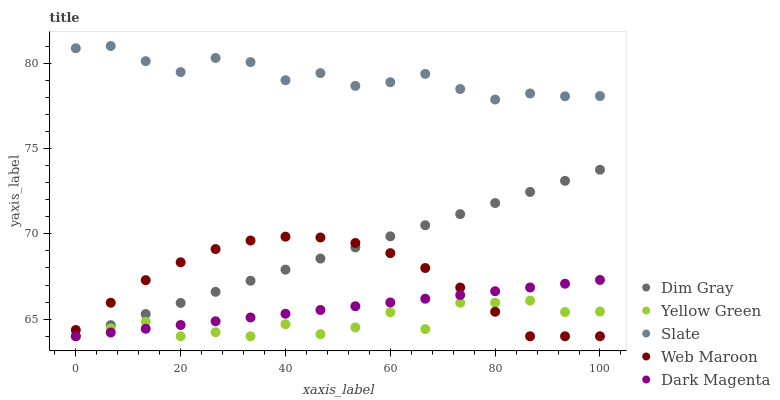Does Yellow Green have the minimum area under the curve?
Answer yes or no. Yes. Does Slate have the maximum area under the curve?
Answer yes or no. Yes. Does Dim Gray have the minimum area under the curve?
Answer yes or no. No. Does Dim Gray have the maximum area under the curve?
Answer yes or no. No. Is Dim Gray the smoothest?
Answer yes or no. Yes. Is Yellow Green the roughest?
Answer yes or no. Yes. Is Web Maroon the smoothest?
Answer yes or no. No. Is Web Maroon the roughest?
Answer yes or no. No. Does Dim Gray have the lowest value?
Answer yes or no. Yes. Does Slate have the highest value?
Answer yes or no. Yes. Does Dim Gray have the highest value?
Answer yes or no. No. Is Dim Gray less than Slate?
Answer yes or no. Yes. Is Slate greater than Dim Gray?
Answer yes or no. Yes. Does Dark Magenta intersect Dim Gray?
Answer yes or no. Yes. Is Dark Magenta less than Dim Gray?
Answer yes or no. No. Is Dark Magenta greater than Dim Gray?
Answer yes or no. No. Does Dim Gray intersect Slate?
Answer yes or no. No. 